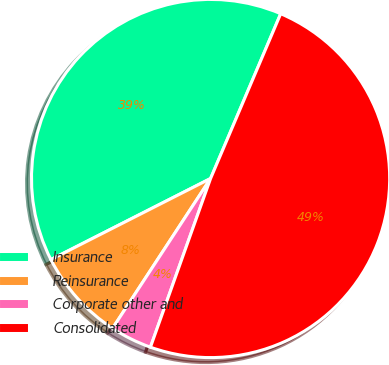Convert chart to OTSL. <chart><loc_0><loc_0><loc_500><loc_500><pie_chart><fcel>Insurance<fcel>Reinsurance<fcel>Corporate other and<fcel>Consolidated<nl><fcel>38.88%<fcel>8.3%<fcel>3.77%<fcel>49.05%<nl></chart> 